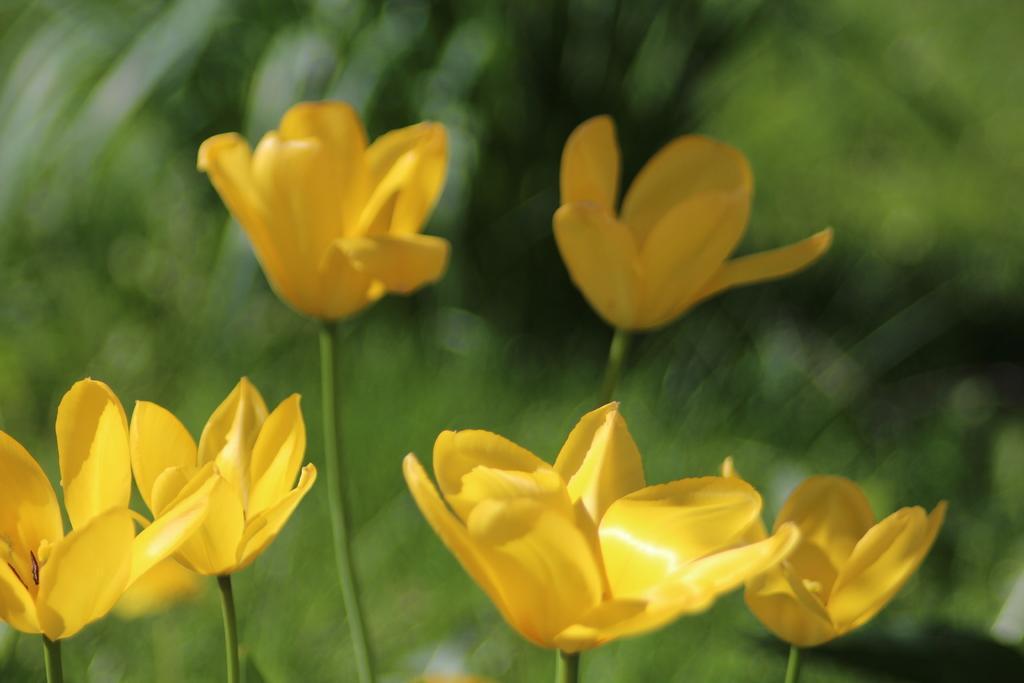Could you give a brief overview of what you see in this image? In the image there are yellow flowers with stems. And there is a green color blur background. 